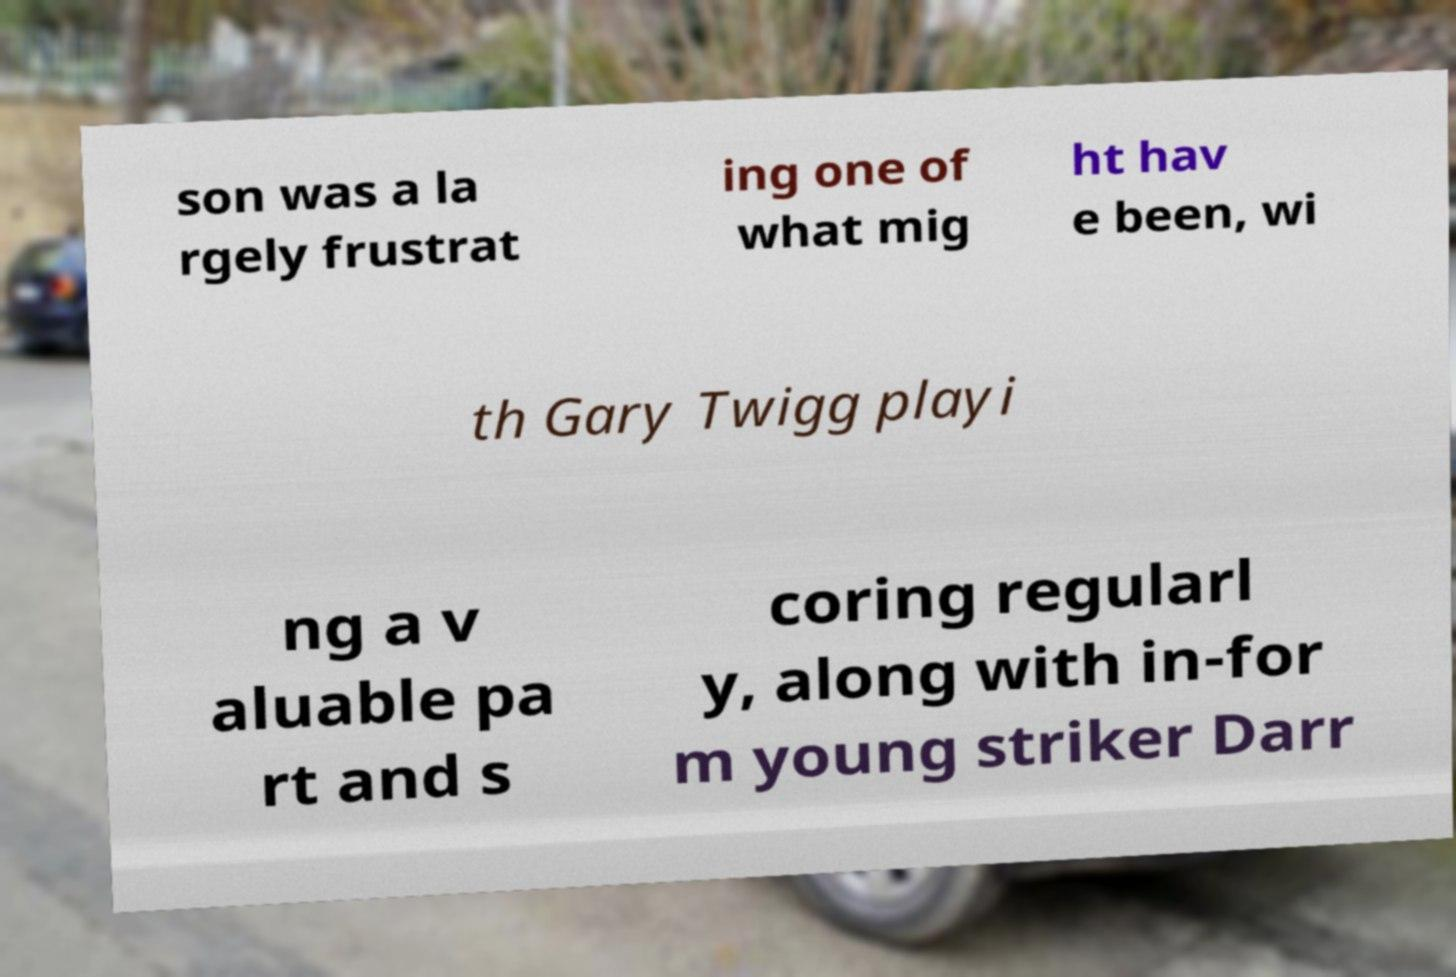Please read and relay the text visible in this image. What does it say? son was a la rgely frustrat ing one of what mig ht hav e been, wi th Gary Twigg playi ng a v aluable pa rt and s coring regularl y, along with in-for m young striker Darr 